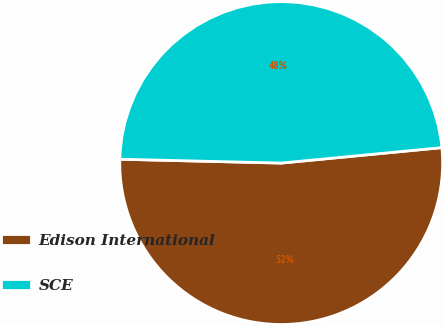<chart> <loc_0><loc_0><loc_500><loc_500><pie_chart><fcel>Edison International<fcel>SCE<nl><fcel>51.91%<fcel>48.09%<nl></chart> 